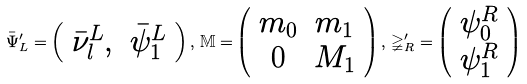<formula> <loc_0><loc_0><loc_500><loc_500>\bar { \Psi } _ { L } ^ { \prime } = \left ( \begin{array} { c c } \bar { \nu } _ { l } ^ { L } , & \bar { \psi } _ { 1 } ^ { L } \end{array} \right ) , \, \mathbb { M = } \left ( \begin{array} { c c } m _ { 0 } & m _ { 1 } \\ 0 & M _ { 1 } \end{array} \right ) , \, \mathbb { \Psi } _ { R } ^ { \prime } = \left ( \begin{array} { c } \psi _ { 0 } ^ { R } \\ \psi _ { 1 } ^ { R } \end{array} \right )</formula> 